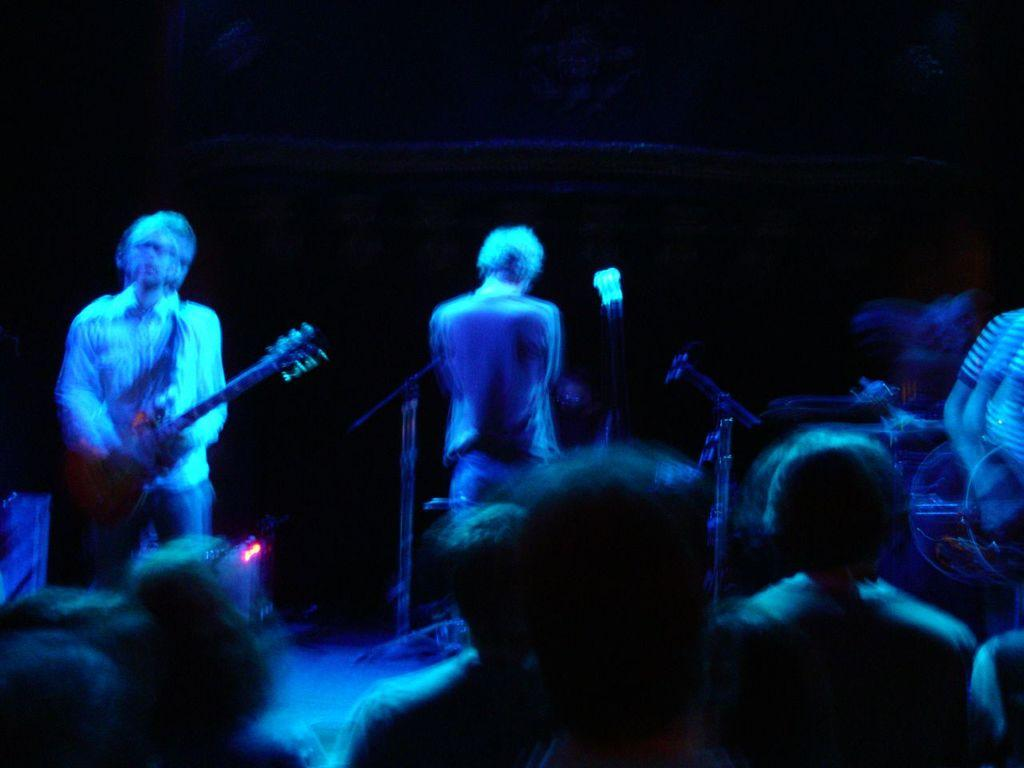What can be seen at the bottom side of the image? There are people at the bottom side of the image. What is the person on the stage doing? The person on the stage is holding a guitar. How many people are visible in the image? There are at least two people visible in the image. What objects can be seen in the background of the image? There are microphones in the background. What type of beef is being sold at the concert in the image? There is no beef or any indication of a sale in the image; it features people at a concert with a person holding a guitar on a stage. How does the person holding the guitar perform magic tricks in the image? There is no mention of magic tricks or any magical elements in the image; the person is simply holding a guitar on a stage. 